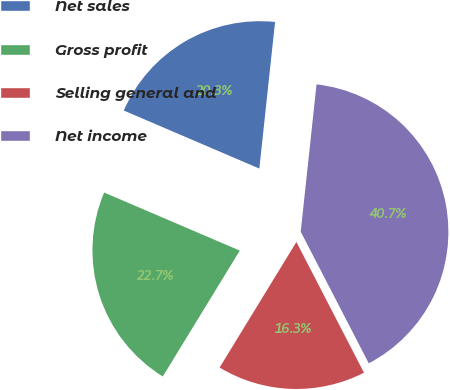<chart> <loc_0><loc_0><loc_500><loc_500><pie_chart><fcel>Net sales<fcel>Gross profit<fcel>Selling general and<fcel>Net income<nl><fcel>20.26%<fcel>22.7%<fcel>16.33%<fcel>40.7%<nl></chart> 